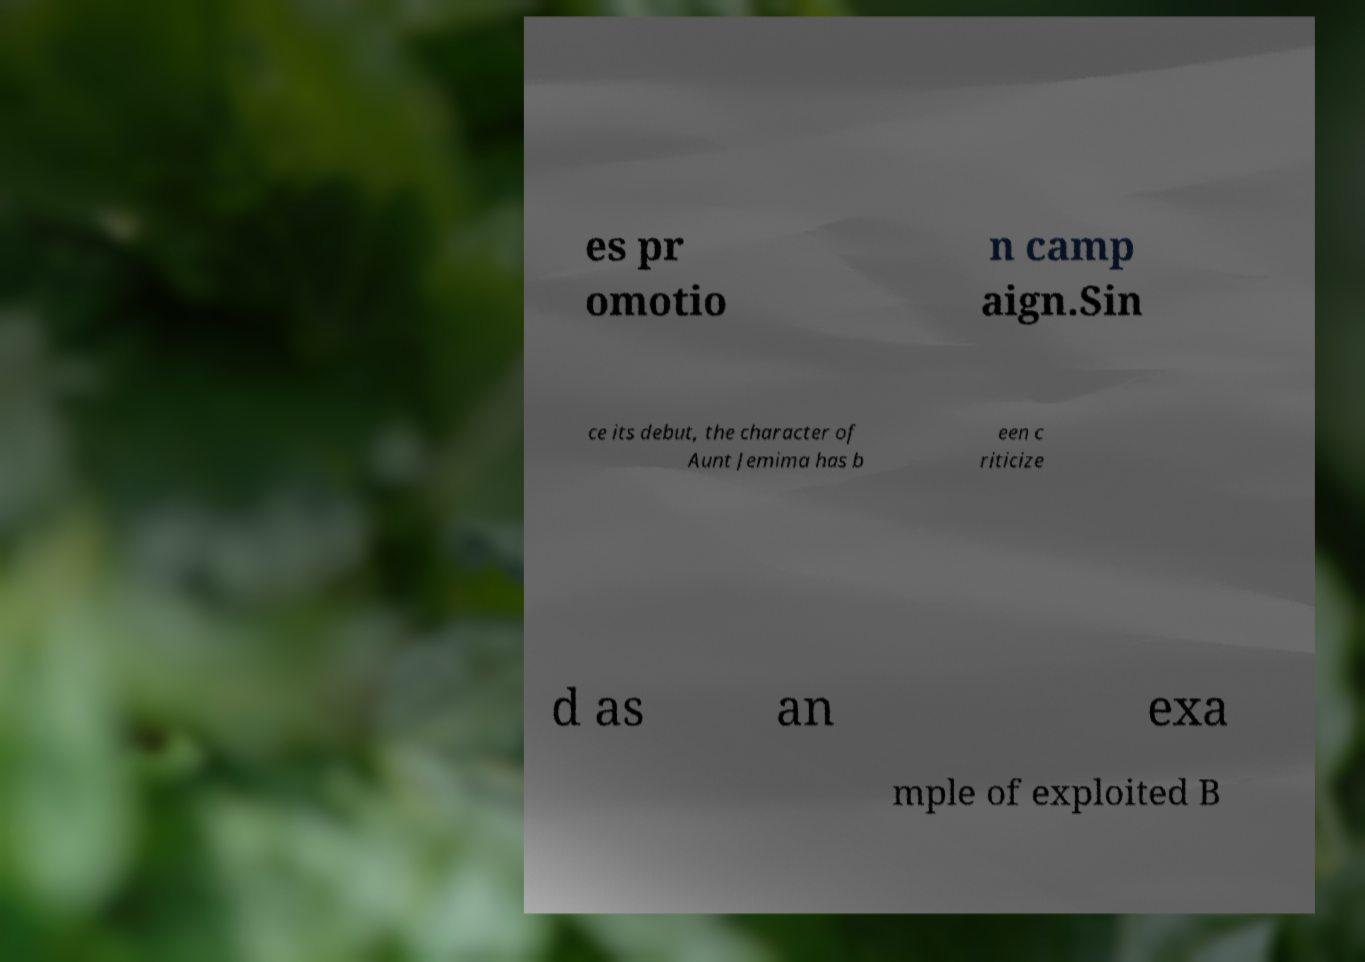Could you assist in decoding the text presented in this image and type it out clearly? es pr omotio n camp aign.Sin ce its debut, the character of Aunt Jemima has b een c riticize d as an exa mple of exploited B 